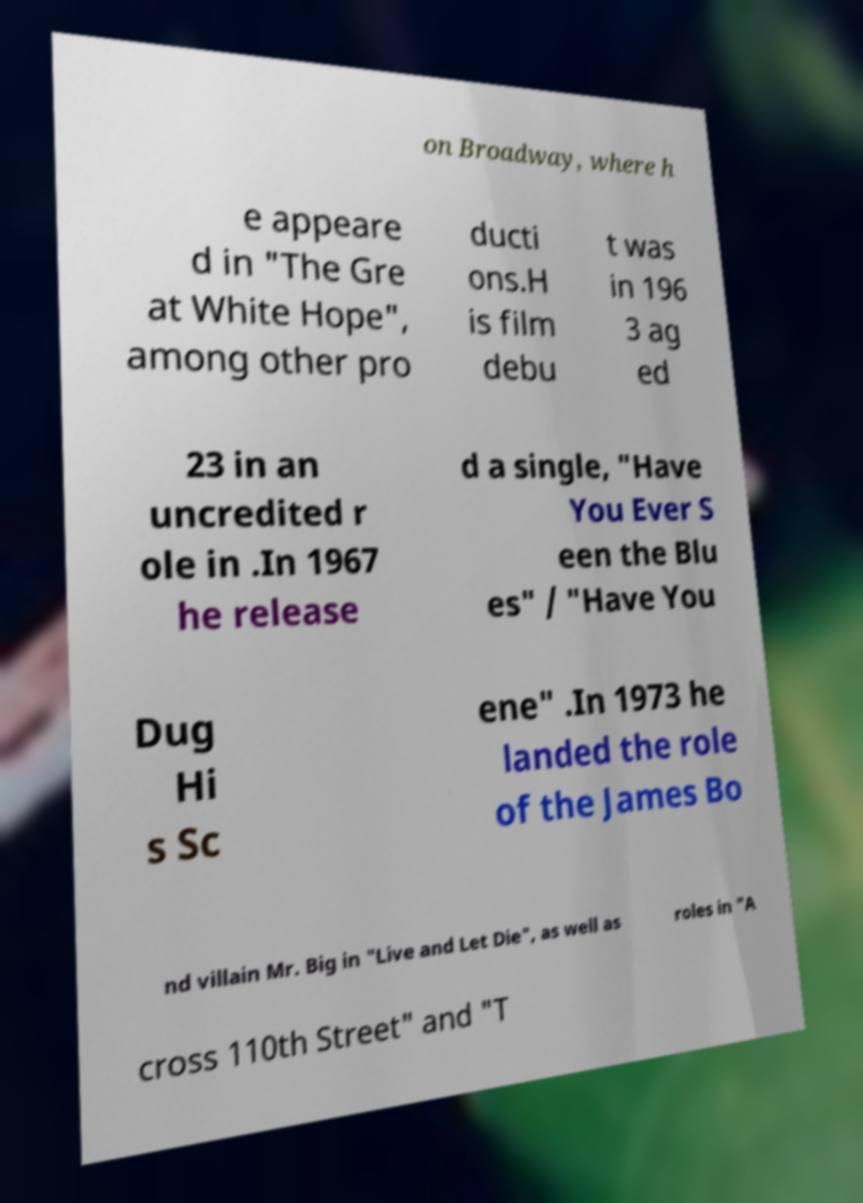There's text embedded in this image that I need extracted. Can you transcribe it verbatim? on Broadway, where h e appeare d in "The Gre at White Hope", among other pro ducti ons.H is film debu t was in 196 3 ag ed 23 in an uncredited r ole in .In 1967 he release d a single, "Have You Ever S een the Blu es" / "Have You Dug Hi s Sc ene" .In 1973 he landed the role of the James Bo nd villain Mr. Big in "Live and Let Die", as well as roles in "A cross 110th Street" and "T 